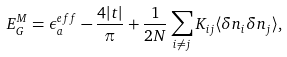<formula> <loc_0><loc_0><loc_500><loc_500>E _ { G } ^ { M } = \epsilon _ { a } ^ { e f f } - \frac { 4 | t | } { \pi } + \frac { 1 } { 2 N } \sum _ { i \neq j } K _ { i j } \langle \delta n _ { i } \delta n _ { j } \rangle ,</formula> 